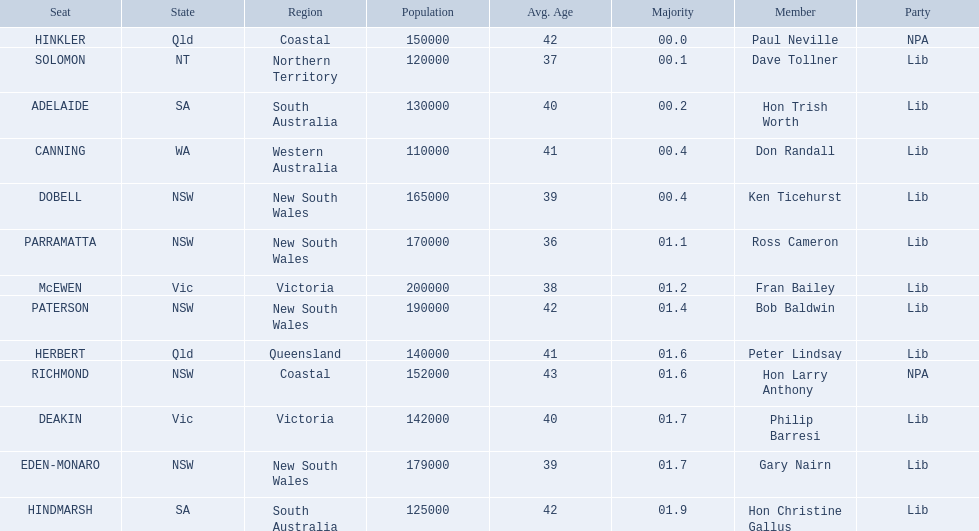What state does hinkler belong too? Qld. What is the majority of difference between sa and qld? 01.9. 